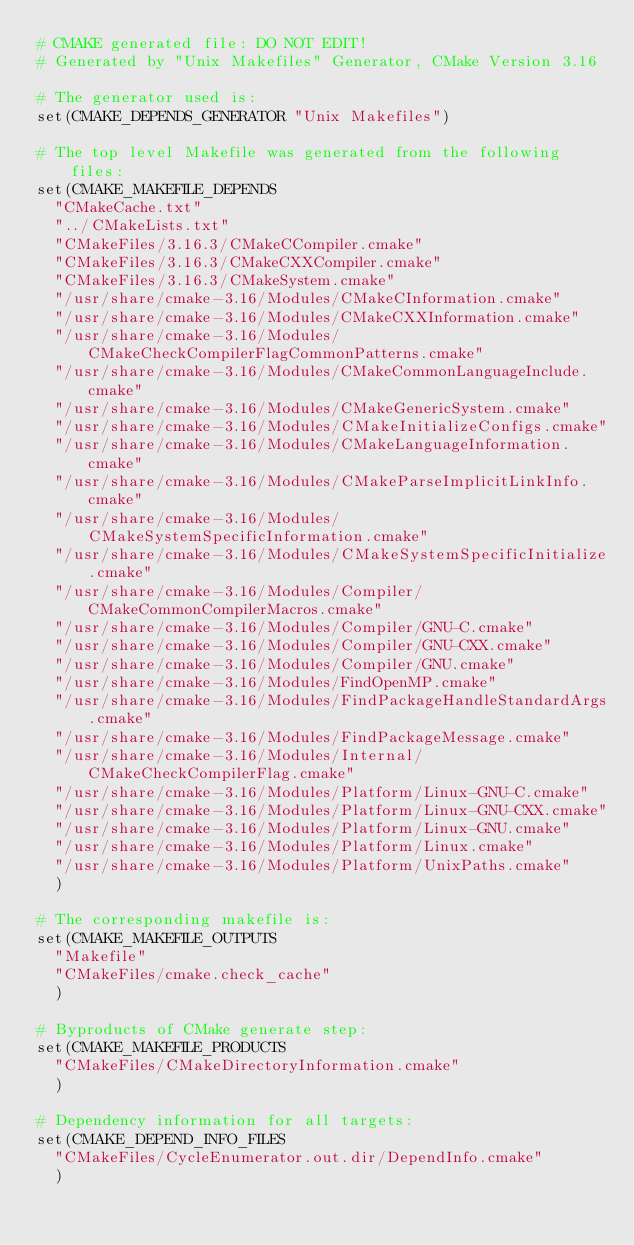<code> <loc_0><loc_0><loc_500><loc_500><_CMake_># CMAKE generated file: DO NOT EDIT!
# Generated by "Unix Makefiles" Generator, CMake Version 3.16

# The generator used is:
set(CMAKE_DEPENDS_GENERATOR "Unix Makefiles")

# The top level Makefile was generated from the following files:
set(CMAKE_MAKEFILE_DEPENDS
  "CMakeCache.txt"
  "../CMakeLists.txt"
  "CMakeFiles/3.16.3/CMakeCCompiler.cmake"
  "CMakeFiles/3.16.3/CMakeCXXCompiler.cmake"
  "CMakeFiles/3.16.3/CMakeSystem.cmake"
  "/usr/share/cmake-3.16/Modules/CMakeCInformation.cmake"
  "/usr/share/cmake-3.16/Modules/CMakeCXXInformation.cmake"
  "/usr/share/cmake-3.16/Modules/CMakeCheckCompilerFlagCommonPatterns.cmake"
  "/usr/share/cmake-3.16/Modules/CMakeCommonLanguageInclude.cmake"
  "/usr/share/cmake-3.16/Modules/CMakeGenericSystem.cmake"
  "/usr/share/cmake-3.16/Modules/CMakeInitializeConfigs.cmake"
  "/usr/share/cmake-3.16/Modules/CMakeLanguageInformation.cmake"
  "/usr/share/cmake-3.16/Modules/CMakeParseImplicitLinkInfo.cmake"
  "/usr/share/cmake-3.16/Modules/CMakeSystemSpecificInformation.cmake"
  "/usr/share/cmake-3.16/Modules/CMakeSystemSpecificInitialize.cmake"
  "/usr/share/cmake-3.16/Modules/Compiler/CMakeCommonCompilerMacros.cmake"
  "/usr/share/cmake-3.16/Modules/Compiler/GNU-C.cmake"
  "/usr/share/cmake-3.16/Modules/Compiler/GNU-CXX.cmake"
  "/usr/share/cmake-3.16/Modules/Compiler/GNU.cmake"
  "/usr/share/cmake-3.16/Modules/FindOpenMP.cmake"
  "/usr/share/cmake-3.16/Modules/FindPackageHandleStandardArgs.cmake"
  "/usr/share/cmake-3.16/Modules/FindPackageMessage.cmake"
  "/usr/share/cmake-3.16/Modules/Internal/CMakeCheckCompilerFlag.cmake"
  "/usr/share/cmake-3.16/Modules/Platform/Linux-GNU-C.cmake"
  "/usr/share/cmake-3.16/Modules/Platform/Linux-GNU-CXX.cmake"
  "/usr/share/cmake-3.16/Modules/Platform/Linux-GNU.cmake"
  "/usr/share/cmake-3.16/Modules/Platform/Linux.cmake"
  "/usr/share/cmake-3.16/Modules/Platform/UnixPaths.cmake"
  )

# The corresponding makefile is:
set(CMAKE_MAKEFILE_OUTPUTS
  "Makefile"
  "CMakeFiles/cmake.check_cache"
  )

# Byproducts of CMake generate step:
set(CMAKE_MAKEFILE_PRODUCTS
  "CMakeFiles/CMakeDirectoryInformation.cmake"
  )

# Dependency information for all targets:
set(CMAKE_DEPEND_INFO_FILES
  "CMakeFiles/CycleEnumerator.out.dir/DependInfo.cmake"
  )
</code> 